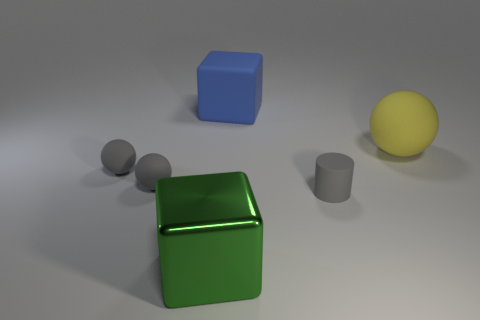How many objects are either big cubes in front of the blue matte thing or big rubber objects right of the large blue matte cube?
Your answer should be very brief. 2. The rubber thing that is the same shape as the large metal object is what color?
Make the answer very short. Blue. How many matte balls are the same color as the matte cube?
Provide a short and direct response. 0. Is the color of the shiny block the same as the matte block?
Your answer should be very brief. No. What number of things are either gray rubber things on the right side of the large metal thing or small green shiny balls?
Your answer should be compact. 1. There is a large rubber object on the right side of the block behind the large object in front of the large yellow rubber ball; what color is it?
Ensure brevity in your answer.  Yellow. What is the color of the large block that is made of the same material as the gray cylinder?
Offer a terse response. Blue. What number of large green things are the same material as the small cylinder?
Provide a succinct answer. 0. Does the ball on the right side of the gray cylinder have the same size as the blue rubber object?
Give a very brief answer. Yes. The other block that is the same size as the blue rubber block is what color?
Your response must be concise. Green. 